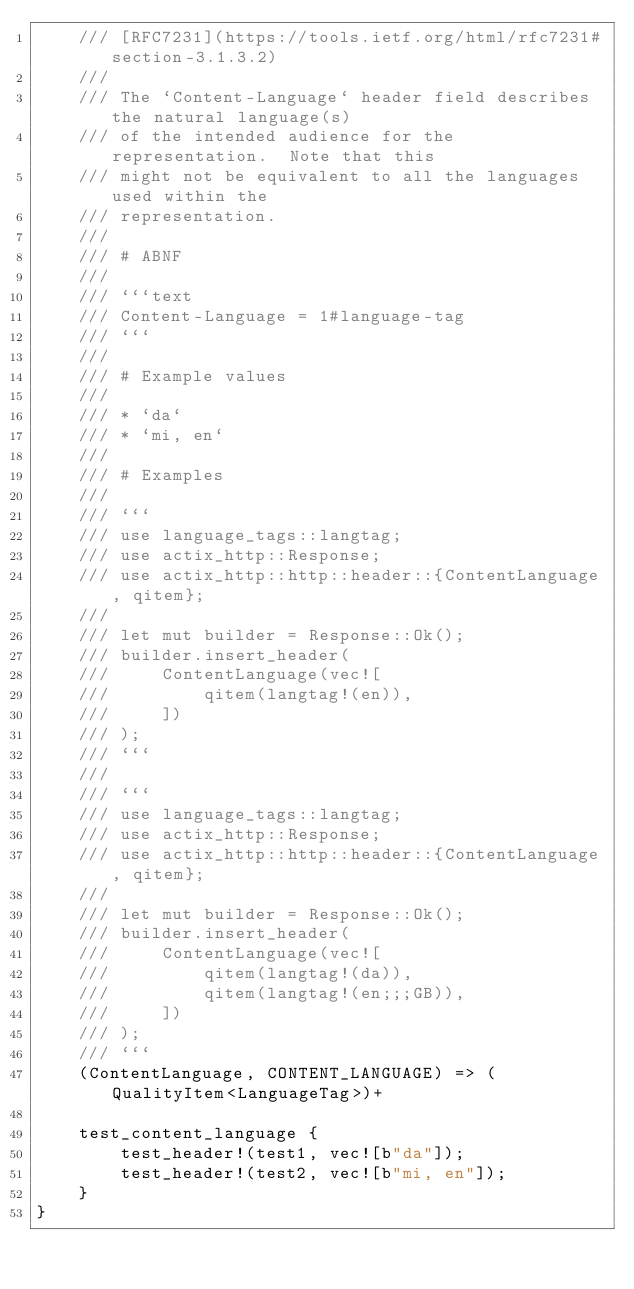Convert code to text. <code><loc_0><loc_0><loc_500><loc_500><_Rust_>    /// [RFC7231](https://tools.ietf.org/html/rfc7231#section-3.1.3.2)
    ///
    /// The `Content-Language` header field describes the natural language(s)
    /// of the intended audience for the representation.  Note that this
    /// might not be equivalent to all the languages used within the
    /// representation.
    ///
    /// # ABNF
    ///
    /// ```text
    /// Content-Language = 1#language-tag
    /// ```
    ///
    /// # Example values
    ///
    /// * `da`
    /// * `mi, en`
    ///
    /// # Examples
    ///
    /// ```
    /// use language_tags::langtag;
    /// use actix_http::Response;
    /// use actix_http::http::header::{ContentLanguage, qitem};
    ///
    /// let mut builder = Response::Ok();
    /// builder.insert_header(
    ///     ContentLanguage(vec![
    ///         qitem(langtag!(en)),
    ///     ])
    /// );
    /// ```
    ///
    /// ```
    /// use language_tags::langtag;
    /// use actix_http::Response;
    /// use actix_http::http::header::{ContentLanguage, qitem};
    ///
    /// let mut builder = Response::Ok();
    /// builder.insert_header(
    ///     ContentLanguage(vec![
    ///         qitem(langtag!(da)),
    ///         qitem(langtag!(en;;;GB)),
    ///     ])
    /// );
    /// ```
    (ContentLanguage, CONTENT_LANGUAGE) => (QualityItem<LanguageTag>)+

    test_content_language {
        test_header!(test1, vec![b"da"]);
        test_header!(test2, vec![b"mi, en"]);
    }
}
</code> 